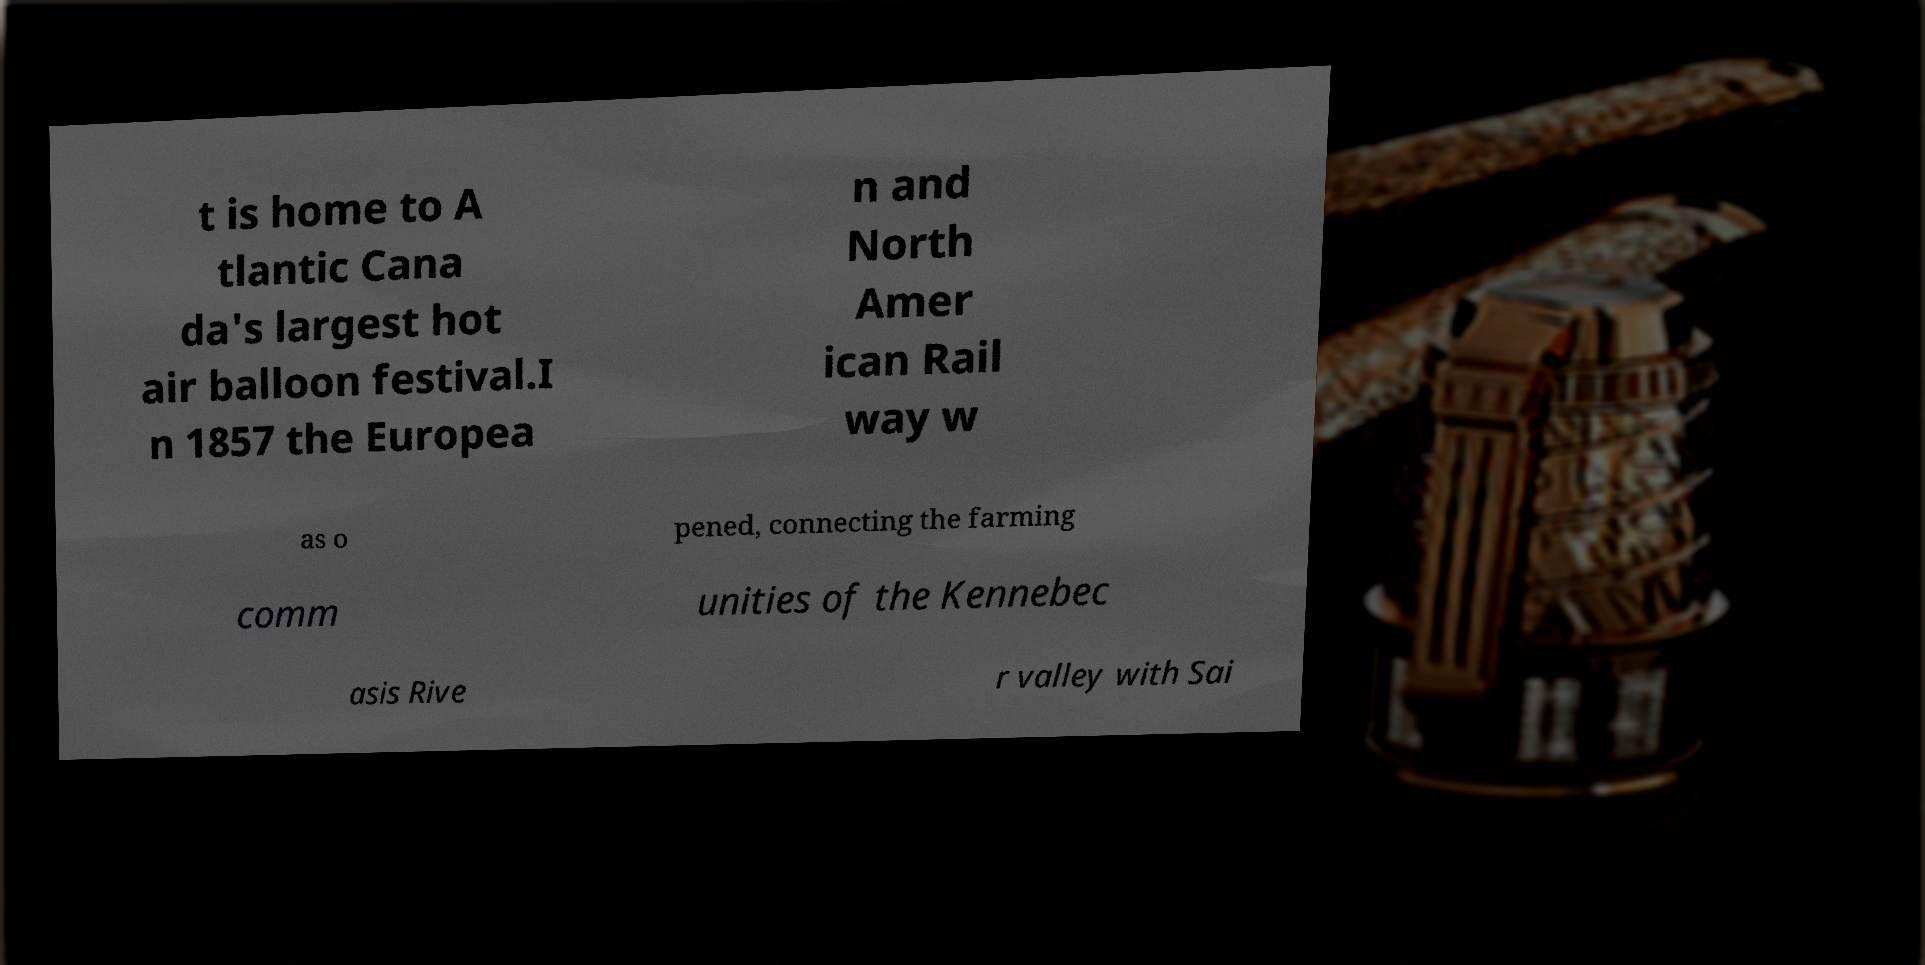For documentation purposes, I need the text within this image transcribed. Could you provide that? t is home to A tlantic Cana da's largest hot air balloon festival.I n 1857 the Europea n and North Amer ican Rail way w as o pened, connecting the farming comm unities of the Kennebec asis Rive r valley with Sai 